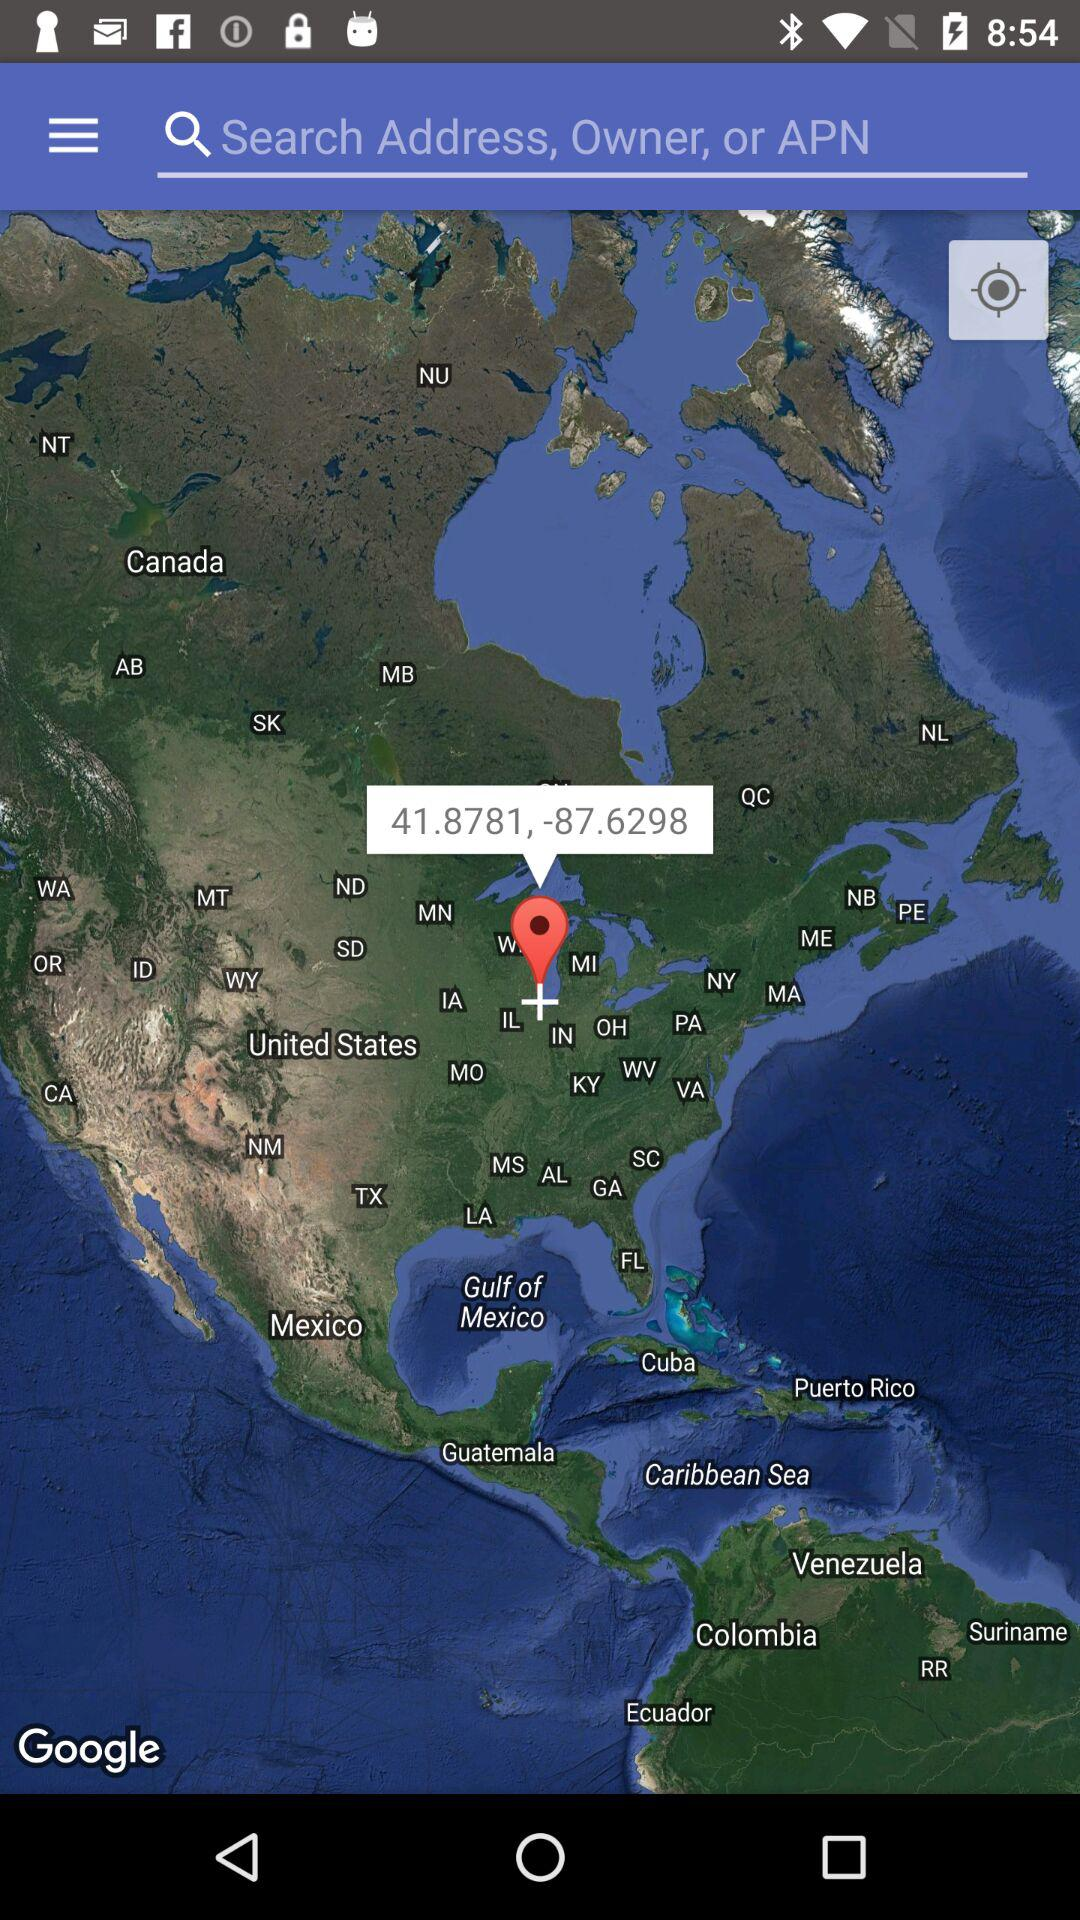What is the latitude and longitude of the current location?
Answer the question using a single word or phrase. 41.8781,-87.6296 